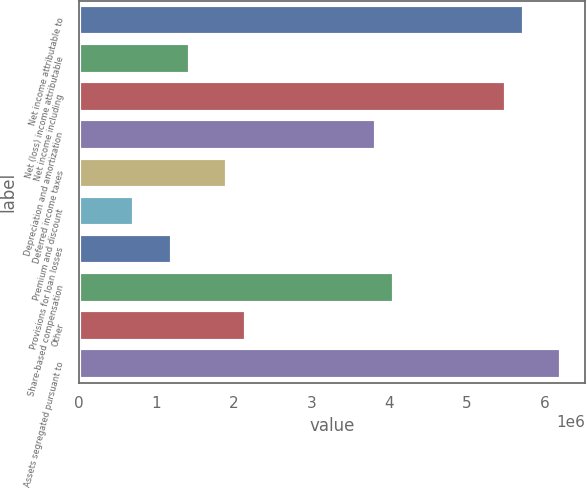<chart> <loc_0><loc_0><loc_500><loc_500><bar_chart><fcel>Net income attributable to<fcel>Net (loss) income attributable<fcel>Net income including<fcel>Depreciation and amortization<fcel>Deferred income taxes<fcel>Premium and discount<fcel>Provisions for loan losses<fcel>Share-based compensation<fcel>Other<fcel>Assets segregated pursuant to<nl><fcel>5.73732e+06<fcel>1.43531e+06<fcel>5.49832e+06<fcel>3.82531e+06<fcel>1.91331e+06<fcel>718307<fcel>1.19631e+06<fcel>4.06432e+06<fcel>2.15231e+06<fcel>6.21532e+06<nl></chart> 